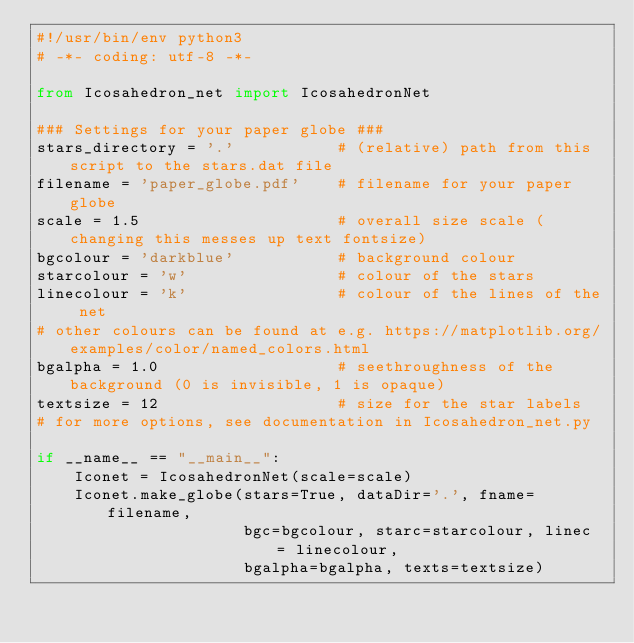Convert code to text. <code><loc_0><loc_0><loc_500><loc_500><_Python_>#!/usr/bin/env python3
# -*- coding: utf-8 -*-

from Icosahedron_net import IcosahedronNet

### Settings for your paper globe ###
stars_directory = '.'           # (relative) path from this script to the stars.dat file
filename = 'paper_globe.pdf'    # filename for your paper globe
scale = 1.5                     # overall size scale (changing this messes up text fontsize)
bgcolour = 'darkblue'           # background colour
starcolour = 'w'                # colour of the stars
linecolour = 'k'                # colour of the lines of the net
# other colours can be found at e.g. https://matplotlib.org/examples/color/named_colors.html
bgalpha = 1.0                   # seethroughness of the background (0 is invisible, 1 is opaque)
textsize = 12                   # size for the star labels
# for more options, see documentation in Icosahedron_net.py

if __name__ == "__main__":
    Iconet = IcosahedronNet(scale=scale)
    Iconet.make_globe(stars=True, dataDir='.', fname=filename,
                      bgc=bgcolour, starc=starcolour, linec = linecolour, 
                      bgalpha=bgalpha, texts=textsize)

</code> 